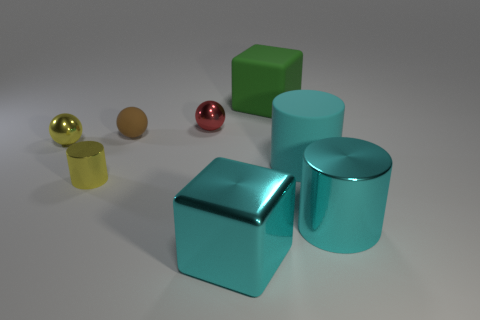What number of big cubes are in front of the tiny red sphere and behind the cyan metal cylinder?
Provide a short and direct response. 0. The yellow thing behind the matte object in front of the small yellow metal ball is made of what material?
Your answer should be compact. Metal. There is a big cyan object that is the same shape as the large green matte object; what material is it?
Your response must be concise. Metal. Is there a large block?
Your answer should be very brief. Yes. The small red object that is the same material as the tiny yellow cylinder is what shape?
Your answer should be very brief. Sphere. What is the material of the big cube behind the tiny red metallic object?
Offer a terse response. Rubber. Is the color of the metal sphere that is left of the small red thing the same as the big shiny block?
Offer a very short reply. No. How big is the block that is in front of the cyan matte object on the right side of the red metal object?
Your answer should be very brief. Large. Is the number of big green objects in front of the cyan rubber thing greater than the number of green cubes?
Your response must be concise. No. Are there an equal number of big objects and big cyan matte cylinders?
Your answer should be compact. No. 